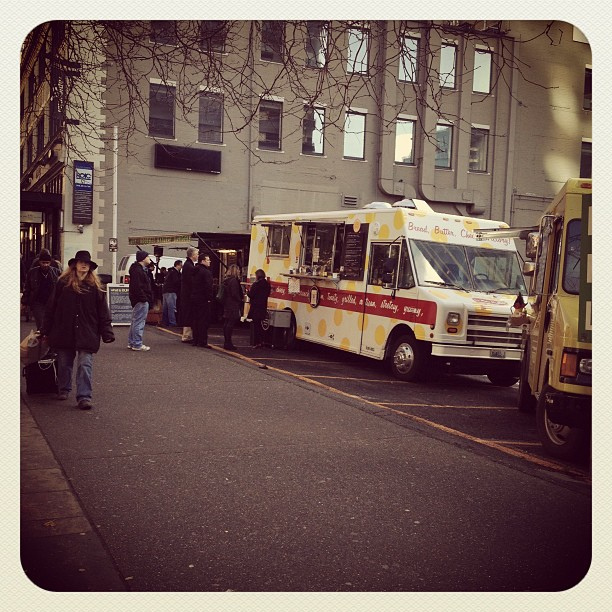Can you notice any interesting details about the people in the image? Yes, one individual is carrying what appears to be a briefcase, possibly indicating they are on a break from work or heading to their office. The attire of the people suggests a casual, perhaps workday lunchtime environment. Do the surroundings provide any clues about the location? The buildings in the background possess a commercial architectural style, with large windows and signs indicative of an urban setting. This, combined with the presence of the food trucks, hint at a bustling city area, possibly a downtown district. 